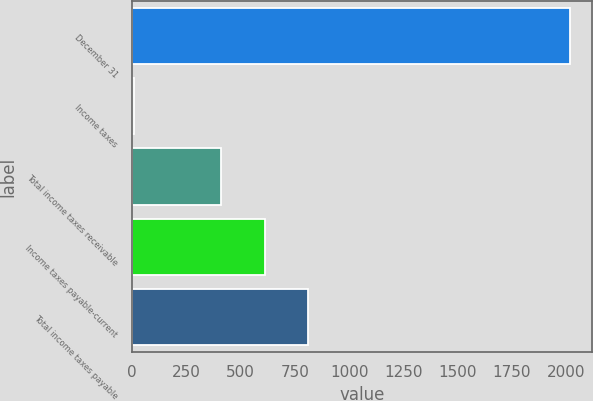Convert chart. <chart><loc_0><loc_0><loc_500><loc_500><bar_chart><fcel>December 31<fcel>Income taxes<fcel>Total income taxes receivable<fcel>Income taxes payable-current<fcel>Total income taxes payable<nl><fcel>2018<fcel>7<fcel>409.2<fcel>610.3<fcel>811.4<nl></chart> 